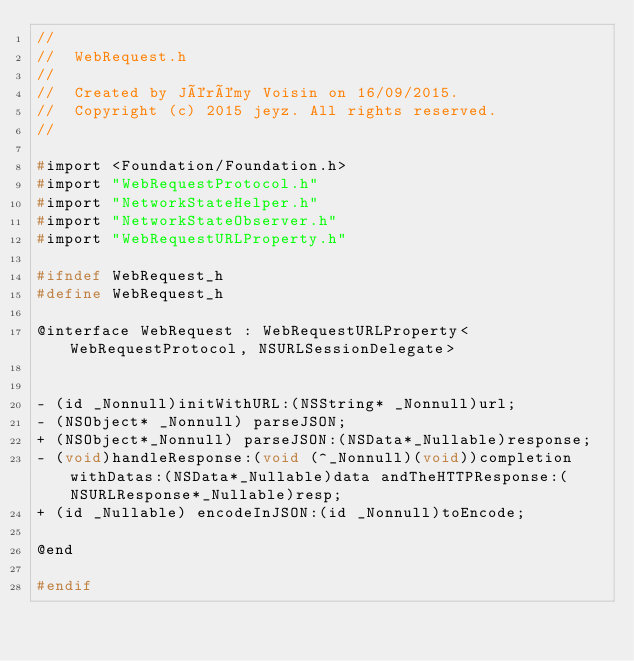<code> <loc_0><loc_0><loc_500><loc_500><_C_>//
//  WebRequest.h
//
//  Created by Jérémy Voisin on 16/09/2015.
//  Copyright (c) 2015 jeyz. All rights reserved.
//

#import <Foundation/Foundation.h>
#import "WebRequestProtocol.h"
#import "NetworkStateHelper.h"
#import "NetworkStateObserver.h"
#import "WebRequestURLProperty.h"

#ifndef WebRequest_h
#define WebRequest_h

@interface WebRequest : WebRequestURLProperty<WebRequestProtocol, NSURLSessionDelegate>


- (id _Nonnull)initWithURL:(NSString* _Nonnull)url;
- (NSObject* _Nonnull) parseJSON;
+ (NSObject*_Nonnull) parseJSON:(NSData*_Nullable)response;
- (void)handleResponse:(void (^_Nonnull)(void))completion withDatas:(NSData*_Nullable)data andTheHTTPResponse:(NSURLResponse*_Nullable)resp;
+ (id _Nullable) encodeInJSON:(id _Nonnull)toEncode;

@end

#endif
</code> 